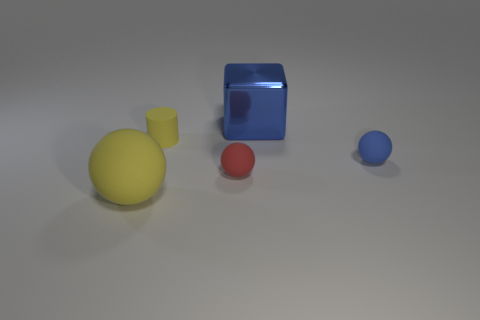Add 2 yellow matte objects. How many objects exist? 7 Subtract all cubes. How many objects are left? 4 Subtract all red things. Subtract all yellow spheres. How many objects are left? 3 Add 1 small balls. How many small balls are left? 3 Add 4 big blue metallic blocks. How many big blue metallic blocks exist? 5 Subtract 1 yellow spheres. How many objects are left? 4 